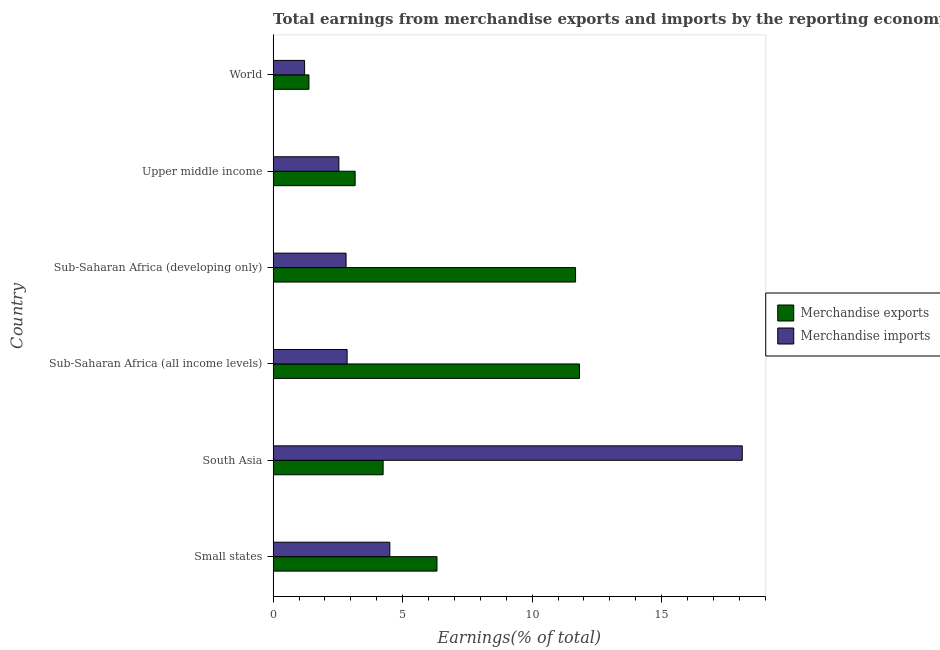How many different coloured bars are there?
Offer a terse response. 2. How many groups of bars are there?
Your answer should be very brief. 6. Are the number of bars per tick equal to the number of legend labels?
Your answer should be very brief. Yes. Are the number of bars on each tick of the Y-axis equal?
Ensure brevity in your answer.  Yes. How many bars are there on the 1st tick from the top?
Offer a very short reply. 2. How many bars are there on the 6th tick from the bottom?
Keep it short and to the point. 2. What is the label of the 1st group of bars from the top?
Offer a terse response. World. In how many cases, is the number of bars for a given country not equal to the number of legend labels?
Give a very brief answer. 0. What is the earnings from merchandise imports in Upper middle income?
Offer a terse response. 2.54. Across all countries, what is the maximum earnings from merchandise imports?
Provide a short and direct response. 18.11. Across all countries, what is the minimum earnings from merchandise imports?
Offer a very short reply. 1.21. In which country was the earnings from merchandise imports maximum?
Offer a very short reply. South Asia. What is the total earnings from merchandise imports in the graph?
Keep it short and to the point. 32.04. What is the difference between the earnings from merchandise imports in Small states and that in South Asia?
Ensure brevity in your answer.  -13.61. What is the difference between the earnings from merchandise imports in Sub-Saharan Africa (all income levels) and the earnings from merchandise exports in Sub-Saharan Africa (developing only)?
Provide a short and direct response. -8.82. What is the average earnings from merchandise imports per country?
Ensure brevity in your answer.  5.34. What is the difference between the earnings from merchandise exports and earnings from merchandise imports in Sub-Saharan Africa (all income levels)?
Ensure brevity in your answer.  8.97. In how many countries, is the earnings from merchandise exports greater than 17 %?
Make the answer very short. 0. Is the earnings from merchandise imports in South Asia less than that in Sub-Saharan Africa (developing only)?
Make the answer very short. No. Is the difference between the earnings from merchandise imports in Sub-Saharan Africa (all income levels) and Sub-Saharan Africa (developing only) greater than the difference between the earnings from merchandise exports in Sub-Saharan Africa (all income levels) and Sub-Saharan Africa (developing only)?
Give a very brief answer. No. What is the difference between the highest and the second highest earnings from merchandise imports?
Make the answer very short. 13.61. In how many countries, is the earnings from merchandise exports greater than the average earnings from merchandise exports taken over all countries?
Offer a terse response. 2. What does the 1st bar from the bottom in Sub-Saharan Africa (all income levels) represents?
Offer a terse response. Merchandise exports. What is the difference between two consecutive major ticks on the X-axis?
Provide a succinct answer. 5. Does the graph contain any zero values?
Your answer should be very brief. No. Does the graph contain grids?
Make the answer very short. No. Where does the legend appear in the graph?
Provide a short and direct response. Center right. How many legend labels are there?
Provide a short and direct response. 2. What is the title of the graph?
Your answer should be very brief. Total earnings from merchandise exports and imports by the reporting economy(residual) in 2000. What is the label or title of the X-axis?
Provide a succinct answer. Earnings(% of total). What is the label or title of the Y-axis?
Keep it short and to the point. Country. What is the Earnings(% of total) of Merchandise exports in Small states?
Keep it short and to the point. 6.33. What is the Earnings(% of total) in Merchandise imports in Small states?
Provide a succinct answer. 4.51. What is the Earnings(% of total) in Merchandise exports in South Asia?
Ensure brevity in your answer.  4.25. What is the Earnings(% of total) of Merchandise imports in South Asia?
Offer a terse response. 18.11. What is the Earnings(% of total) in Merchandise exports in Sub-Saharan Africa (all income levels)?
Keep it short and to the point. 11.83. What is the Earnings(% of total) in Merchandise imports in Sub-Saharan Africa (all income levels)?
Provide a succinct answer. 2.86. What is the Earnings(% of total) in Merchandise exports in Sub-Saharan Africa (developing only)?
Make the answer very short. 11.68. What is the Earnings(% of total) of Merchandise imports in Sub-Saharan Africa (developing only)?
Keep it short and to the point. 2.82. What is the Earnings(% of total) in Merchandise exports in Upper middle income?
Provide a short and direct response. 3.17. What is the Earnings(% of total) in Merchandise imports in Upper middle income?
Provide a succinct answer. 2.54. What is the Earnings(% of total) of Merchandise exports in World?
Make the answer very short. 1.38. What is the Earnings(% of total) in Merchandise imports in World?
Your answer should be very brief. 1.21. Across all countries, what is the maximum Earnings(% of total) in Merchandise exports?
Make the answer very short. 11.83. Across all countries, what is the maximum Earnings(% of total) of Merchandise imports?
Provide a short and direct response. 18.11. Across all countries, what is the minimum Earnings(% of total) of Merchandise exports?
Keep it short and to the point. 1.38. Across all countries, what is the minimum Earnings(% of total) in Merchandise imports?
Provide a short and direct response. 1.21. What is the total Earnings(% of total) of Merchandise exports in the graph?
Your answer should be compact. 38.62. What is the total Earnings(% of total) in Merchandise imports in the graph?
Provide a succinct answer. 32.04. What is the difference between the Earnings(% of total) in Merchandise exports in Small states and that in South Asia?
Ensure brevity in your answer.  2.08. What is the difference between the Earnings(% of total) of Merchandise imports in Small states and that in South Asia?
Give a very brief answer. -13.61. What is the difference between the Earnings(% of total) in Merchandise exports in Small states and that in Sub-Saharan Africa (all income levels)?
Provide a succinct answer. -5.5. What is the difference between the Earnings(% of total) in Merchandise imports in Small states and that in Sub-Saharan Africa (all income levels)?
Offer a very short reply. 1.65. What is the difference between the Earnings(% of total) of Merchandise exports in Small states and that in Sub-Saharan Africa (developing only)?
Your answer should be compact. -5.35. What is the difference between the Earnings(% of total) in Merchandise imports in Small states and that in Sub-Saharan Africa (developing only)?
Your answer should be compact. 1.69. What is the difference between the Earnings(% of total) of Merchandise exports in Small states and that in Upper middle income?
Keep it short and to the point. 3.16. What is the difference between the Earnings(% of total) in Merchandise imports in Small states and that in Upper middle income?
Make the answer very short. 1.97. What is the difference between the Earnings(% of total) in Merchandise exports in Small states and that in World?
Your answer should be very brief. 4.94. What is the difference between the Earnings(% of total) of Merchandise imports in Small states and that in World?
Your answer should be very brief. 3.29. What is the difference between the Earnings(% of total) in Merchandise exports in South Asia and that in Sub-Saharan Africa (all income levels)?
Your response must be concise. -7.58. What is the difference between the Earnings(% of total) in Merchandise imports in South Asia and that in Sub-Saharan Africa (all income levels)?
Provide a short and direct response. 15.25. What is the difference between the Earnings(% of total) in Merchandise exports in South Asia and that in Sub-Saharan Africa (developing only)?
Ensure brevity in your answer.  -7.43. What is the difference between the Earnings(% of total) of Merchandise imports in South Asia and that in Sub-Saharan Africa (developing only)?
Provide a short and direct response. 15.29. What is the difference between the Earnings(% of total) in Merchandise exports in South Asia and that in Upper middle income?
Offer a terse response. 1.08. What is the difference between the Earnings(% of total) of Merchandise imports in South Asia and that in Upper middle income?
Your response must be concise. 15.57. What is the difference between the Earnings(% of total) of Merchandise exports in South Asia and that in World?
Your response must be concise. 2.86. What is the difference between the Earnings(% of total) in Merchandise imports in South Asia and that in World?
Offer a very short reply. 16.9. What is the difference between the Earnings(% of total) of Merchandise exports in Sub-Saharan Africa (all income levels) and that in Sub-Saharan Africa (developing only)?
Provide a short and direct response. 0.15. What is the difference between the Earnings(% of total) in Merchandise imports in Sub-Saharan Africa (all income levels) and that in Sub-Saharan Africa (developing only)?
Give a very brief answer. 0.04. What is the difference between the Earnings(% of total) in Merchandise exports in Sub-Saharan Africa (all income levels) and that in Upper middle income?
Offer a terse response. 8.66. What is the difference between the Earnings(% of total) of Merchandise imports in Sub-Saharan Africa (all income levels) and that in Upper middle income?
Keep it short and to the point. 0.32. What is the difference between the Earnings(% of total) in Merchandise exports in Sub-Saharan Africa (all income levels) and that in World?
Give a very brief answer. 10.44. What is the difference between the Earnings(% of total) in Merchandise imports in Sub-Saharan Africa (all income levels) and that in World?
Your response must be concise. 1.64. What is the difference between the Earnings(% of total) in Merchandise exports in Sub-Saharan Africa (developing only) and that in Upper middle income?
Offer a terse response. 8.51. What is the difference between the Earnings(% of total) in Merchandise imports in Sub-Saharan Africa (developing only) and that in Upper middle income?
Keep it short and to the point. 0.28. What is the difference between the Earnings(% of total) of Merchandise exports in Sub-Saharan Africa (developing only) and that in World?
Give a very brief answer. 10.29. What is the difference between the Earnings(% of total) of Merchandise imports in Sub-Saharan Africa (developing only) and that in World?
Offer a terse response. 1.6. What is the difference between the Earnings(% of total) in Merchandise exports in Upper middle income and that in World?
Make the answer very short. 1.78. What is the difference between the Earnings(% of total) of Merchandise imports in Upper middle income and that in World?
Give a very brief answer. 1.32. What is the difference between the Earnings(% of total) in Merchandise exports in Small states and the Earnings(% of total) in Merchandise imports in South Asia?
Your answer should be very brief. -11.79. What is the difference between the Earnings(% of total) in Merchandise exports in Small states and the Earnings(% of total) in Merchandise imports in Sub-Saharan Africa (all income levels)?
Your answer should be compact. 3.47. What is the difference between the Earnings(% of total) of Merchandise exports in Small states and the Earnings(% of total) of Merchandise imports in Sub-Saharan Africa (developing only)?
Ensure brevity in your answer.  3.51. What is the difference between the Earnings(% of total) in Merchandise exports in Small states and the Earnings(% of total) in Merchandise imports in Upper middle income?
Keep it short and to the point. 3.79. What is the difference between the Earnings(% of total) of Merchandise exports in Small states and the Earnings(% of total) of Merchandise imports in World?
Your answer should be compact. 5.11. What is the difference between the Earnings(% of total) in Merchandise exports in South Asia and the Earnings(% of total) in Merchandise imports in Sub-Saharan Africa (all income levels)?
Offer a terse response. 1.39. What is the difference between the Earnings(% of total) of Merchandise exports in South Asia and the Earnings(% of total) of Merchandise imports in Sub-Saharan Africa (developing only)?
Provide a succinct answer. 1.43. What is the difference between the Earnings(% of total) in Merchandise exports in South Asia and the Earnings(% of total) in Merchandise imports in Upper middle income?
Make the answer very short. 1.71. What is the difference between the Earnings(% of total) in Merchandise exports in South Asia and the Earnings(% of total) in Merchandise imports in World?
Your answer should be compact. 3.03. What is the difference between the Earnings(% of total) in Merchandise exports in Sub-Saharan Africa (all income levels) and the Earnings(% of total) in Merchandise imports in Sub-Saharan Africa (developing only)?
Offer a terse response. 9.01. What is the difference between the Earnings(% of total) of Merchandise exports in Sub-Saharan Africa (all income levels) and the Earnings(% of total) of Merchandise imports in Upper middle income?
Provide a short and direct response. 9.29. What is the difference between the Earnings(% of total) of Merchandise exports in Sub-Saharan Africa (all income levels) and the Earnings(% of total) of Merchandise imports in World?
Provide a short and direct response. 10.61. What is the difference between the Earnings(% of total) of Merchandise exports in Sub-Saharan Africa (developing only) and the Earnings(% of total) of Merchandise imports in Upper middle income?
Ensure brevity in your answer.  9.14. What is the difference between the Earnings(% of total) of Merchandise exports in Sub-Saharan Africa (developing only) and the Earnings(% of total) of Merchandise imports in World?
Your answer should be very brief. 10.46. What is the difference between the Earnings(% of total) of Merchandise exports in Upper middle income and the Earnings(% of total) of Merchandise imports in World?
Give a very brief answer. 1.95. What is the average Earnings(% of total) of Merchandise exports per country?
Give a very brief answer. 6.44. What is the average Earnings(% of total) of Merchandise imports per country?
Your answer should be very brief. 5.34. What is the difference between the Earnings(% of total) in Merchandise exports and Earnings(% of total) in Merchandise imports in Small states?
Provide a succinct answer. 1.82. What is the difference between the Earnings(% of total) of Merchandise exports and Earnings(% of total) of Merchandise imports in South Asia?
Make the answer very short. -13.86. What is the difference between the Earnings(% of total) in Merchandise exports and Earnings(% of total) in Merchandise imports in Sub-Saharan Africa (all income levels)?
Your answer should be very brief. 8.97. What is the difference between the Earnings(% of total) of Merchandise exports and Earnings(% of total) of Merchandise imports in Sub-Saharan Africa (developing only)?
Make the answer very short. 8.86. What is the difference between the Earnings(% of total) of Merchandise exports and Earnings(% of total) of Merchandise imports in Upper middle income?
Your answer should be very brief. 0.63. What is the difference between the Earnings(% of total) of Merchandise exports and Earnings(% of total) of Merchandise imports in World?
Your response must be concise. 0.17. What is the ratio of the Earnings(% of total) of Merchandise exports in Small states to that in South Asia?
Offer a terse response. 1.49. What is the ratio of the Earnings(% of total) in Merchandise imports in Small states to that in South Asia?
Keep it short and to the point. 0.25. What is the ratio of the Earnings(% of total) in Merchandise exports in Small states to that in Sub-Saharan Africa (all income levels)?
Your response must be concise. 0.53. What is the ratio of the Earnings(% of total) of Merchandise imports in Small states to that in Sub-Saharan Africa (all income levels)?
Give a very brief answer. 1.58. What is the ratio of the Earnings(% of total) in Merchandise exports in Small states to that in Sub-Saharan Africa (developing only)?
Provide a short and direct response. 0.54. What is the ratio of the Earnings(% of total) in Merchandise imports in Small states to that in Sub-Saharan Africa (developing only)?
Your response must be concise. 1.6. What is the ratio of the Earnings(% of total) in Merchandise exports in Small states to that in Upper middle income?
Your answer should be very brief. 2. What is the ratio of the Earnings(% of total) of Merchandise imports in Small states to that in Upper middle income?
Keep it short and to the point. 1.78. What is the ratio of the Earnings(% of total) of Merchandise exports in Small states to that in World?
Ensure brevity in your answer.  4.57. What is the ratio of the Earnings(% of total) in Merchandise imports in Small states to that in World?
Offer a very short reply. 3.71. What is the ratio of the Earnings(% of total) of Merchandise exports in South Asia to that in Sub-Saharan Africa (all income levels)?
Provide a succinct answer. 0.36. What is the ratio of the Earnings(% of total) of Merchandise imports in South Asia to that in Sub-Saharan Africa (all income levels)?
Keep it short and to the point. 6.34. What is the ratio of the Earnings(% of total) of Merchandise exports in South Asia to that in Sub-Saharan Africa (developing only)?
Your answer should be compact. 0.36. What is the ratio of the Earnings(% of total) in Merchandise imports in South Asia to that in Sub-Saharan Africa (developing only)?
Your response must be concise. 6.43. What is the ratio of the Earnings(% of total) in Merchandise exports in South Asia to that in Upper middle income?
Give a very brief answer. 1.34. What is the ratio of the Earnings(% of total) of Merchandise imports in South Asia to that in Upper middle income?
Make the answer very short. 7.14. What is the ratio of the Earnings(% of total) in Merchandise exports in South Asia to that in World?
Ensure brevity in your answer.  3.07. What is the ratio of the Earnings(% of total) in Merchandise imports in South Asia to that in World?
Your answer should be very brief. 14.91. What is the ratio of the Earnings(% of total) in Merchandise exports in Sub-Saharan Africa (all income levels) to that in Sub-Saharan Africa (developing only)?
Your answer should be very brief. 1.01. What is the ratio of the Earnings(% of total) of Merchandise imports in Sub-Saharan Africa (all income levels) to that in Sub-Saharan Africa (developing only)?
Offer a very short reply. 1.01. What is the ratio of the Earnings(% of total) of Merchandise exports in Sub-Saharan Africa (all income levels) to that in Upper middle income?
Offer a terse response. 3.74. What is the ratio of the Earnings(% of total) in Merchandise imports in Sub-Saharan Africa (all income levels) to that in Upper middle income?
Offer a very short reply. 1.13. What is the ratio of the Earnings(% of total) of Merchandise exports in Sub-Saharan Africa (all income levels) to that in World?
Ensure brevity in your answer.  8.55. What is the ratio of the Earnings(% of total) of Merchandise imports in Sub-Saharan Africa (all income levels) to that in World?
Your response must be concise. 2.35. What is the ratio of the Earnings(% of total) in Merchandise exports in Sub-Saharan Africa (developing only) to that in Upper middle income?
Your response must be concise. 3.69. What is the ratio of the Earnings(% of total) in Merchandise imports in Sub-Saharan Africa (developing only) to that in Upper middle income?
Provide a short and direct response. 1.11. What is the ratio of the Earnings(% of total) in Merchandise exports in Sub-Saharan Africa (developing only) to that in World?
Give a very brief answer. 8.44. What is the ratio of the Earnings(% of total) in Merchandise imports in Sub-Saharan Africa (developing only) to that in World?
Your response must be concise. 2.32. What is the ratio of the Earnings(% of total) of Merchandise exports in Upper middle income to that in World?
Keep it short and to the point. 2.29. What is the ratio of the Earnings(% of total) in Merchandise imports in Upper middle income to that in World?
Offer a terse response. 2.09. What is the difference between the highest and the second highest Earnings(% of total) in Merchandise exports?
Keep it short and to the point. 0.15. What is the difference between the highest and the second highest Earnings(% of total) of Merchandise imports?
Your answer should be very brief. 13.61. What is the difference between the highest and the lowest Earnings(% of total) in Merchandise exports?
Provide a succinct answer. 10.44. What is the difference between the highest and the lowest Earnings(% of total) of Merchandise imports?
Provide a succinct answer. 16.9. 